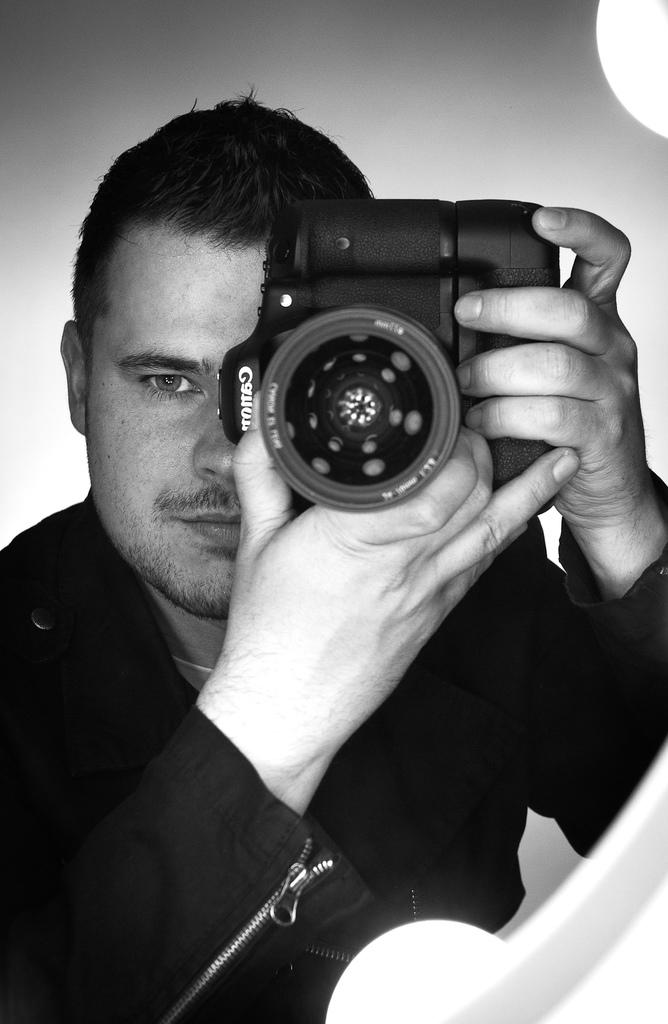What is the main subject of the image? There is a person in the image. What is the person wearing? The person is wearing a black jacket. What is the person holding in their hands? The person is holding a camera in their hands. Can you see the person's brother in the image? There is no mention of a brother in the image, so it cannot be determined if the person's brother is present. 